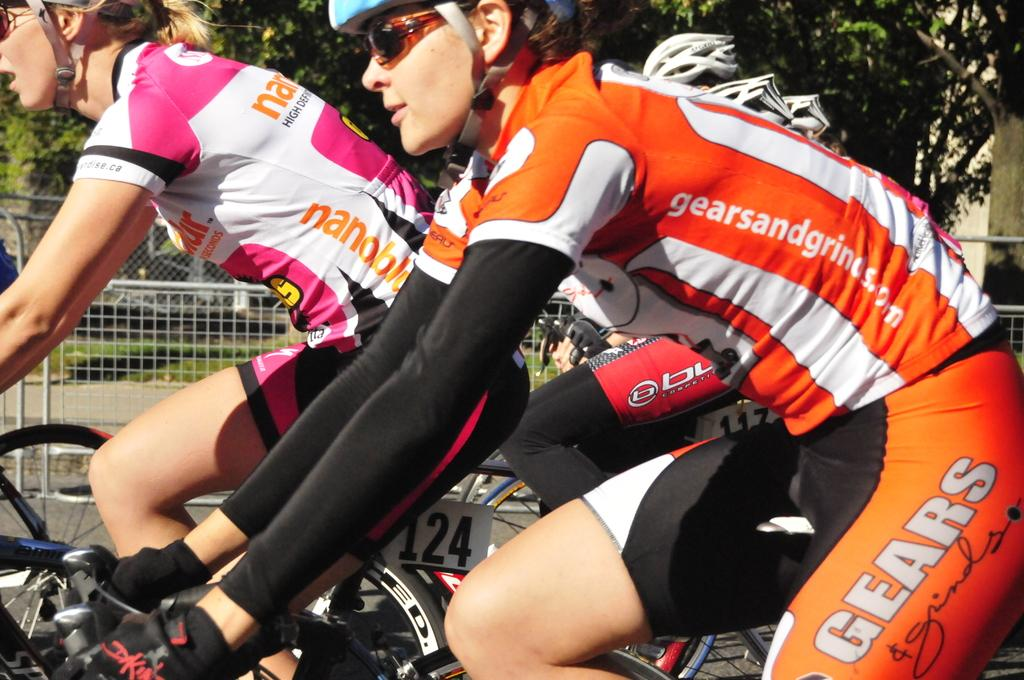What are the people in the image doing? The people in the image are riding cycles. What safety precaution are the people taking while riding cycles? The people are wearing helmets. What can be seen in the background of the image? There are trees, fences, and grass in the background of the image. What is the rate at which the trees are growing in the image? The rate at which the trees are growing cannot be determined from the image, as it only provides a snapshot of the scene. 